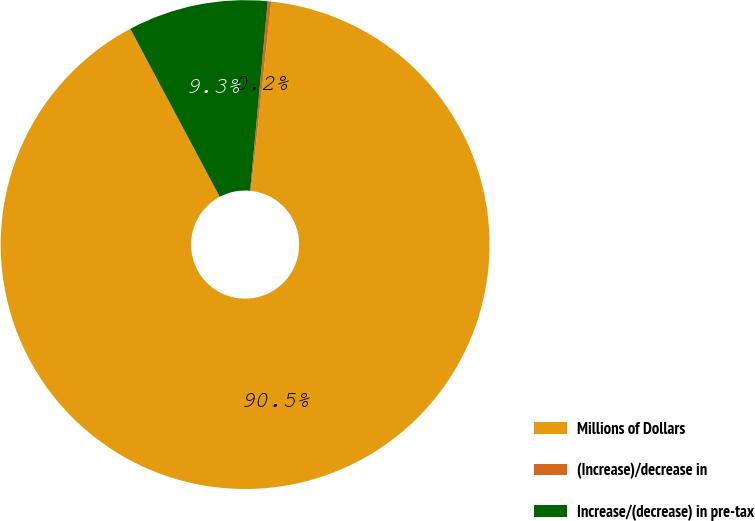Convert chart to OTSL. <chart><loc_0><loc_0><loc_500><loc_500><pie_chart><fcel>Millions of Dollars<fcel>(Increase)/decrease in<fcel>Increase/(decrease) in pre-tax<nl><fcel>90.52%<fcel>0.23%<fcel>9.26%<nl></chart> 